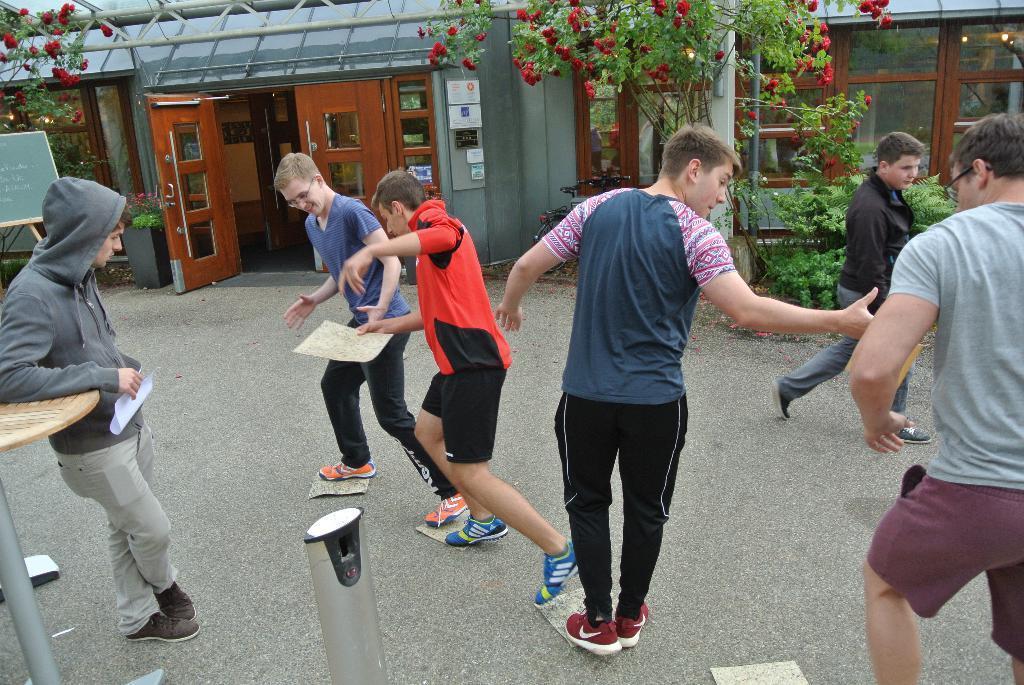Could you give a brief overview of what you see in this image? In this image, we can see few people are standing and walking. Here a person is holding a paper and keeping his hand on the table. here few are holding some object. At the bottom, we can see rods. Background there is a house, wall, glass windows, doors, plants, board, poles and rods. 